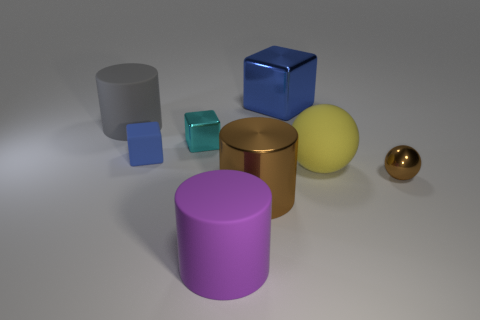There is a matte cube that is behind the brown object that is left of the small thing that is on the right side of the yellow ball; what is its size?
Your answer should be compact. Small. Are there an equal number of rubber objects that are on the left side of the large purple matte cylinder and matte objects on the right side of the tiny metal block?
Ensure brevity in your answer.  Yes. What number of other things are the same color as the tiny shiny ball?
Your answer should be compact. 1. There is a small rubber cube; is it the same color as the big metal object that is behind the yellow thing?
Provide a short and direct response. Yes. How many red objects are either big things or large metal blocks?
Give a very brief answer. 0. Are there the same number of yellow rubber things in front of the large purple thing and large brown objects?
Offer a terse response. No. What color is the other big metal object that is the same shape as the cyan thing?
Provide a short and direct response. Blue. How many large blue things have the same shape as the big yellow matte object?
Ensure brevity in your answer.  0. What material is the thing that is the same color as the large cube?
Your answer should be very brief. Rubber. What number of red blocks are there?
Provide a succinct answer. 0. 